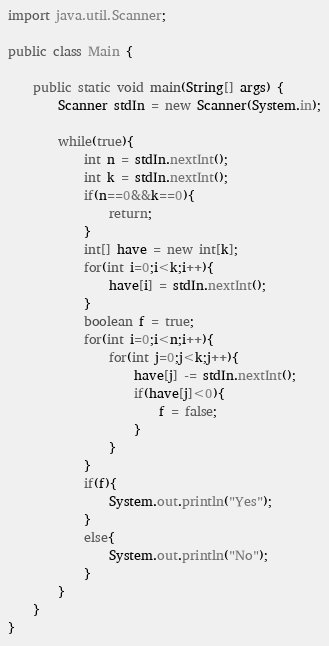Convert code to text. <code><loc_0><loc_0><loc_500><loc_500><_Java_>import java.util.Scanner;

public class Main {

	public static void main(String[] args) {
		Scanner stdIn = new Scanner(System.in);
		
		while(true){
			int n = stdIn.nextInt();
			int k = stdIn.nextInt();
			if(n==0&&k==0){
				return;
			}
			int[] have = new int[k];
			for(int i=0;i<k;i++){
				have[i] = stdIn.nextInt();
			}
			boolean f = true;
			for(int i=0;i<n;i++){
				for(int j=0;j<k;j++){
					have[j] -= stdIn.nextInt();
					if(have[j]<0){
						f = false;
					}
				}
			}
			if(f){
				System.out.println("Yes");
			}
			else{
				System.out.println("No");
			}
		}
	}
}</code> 